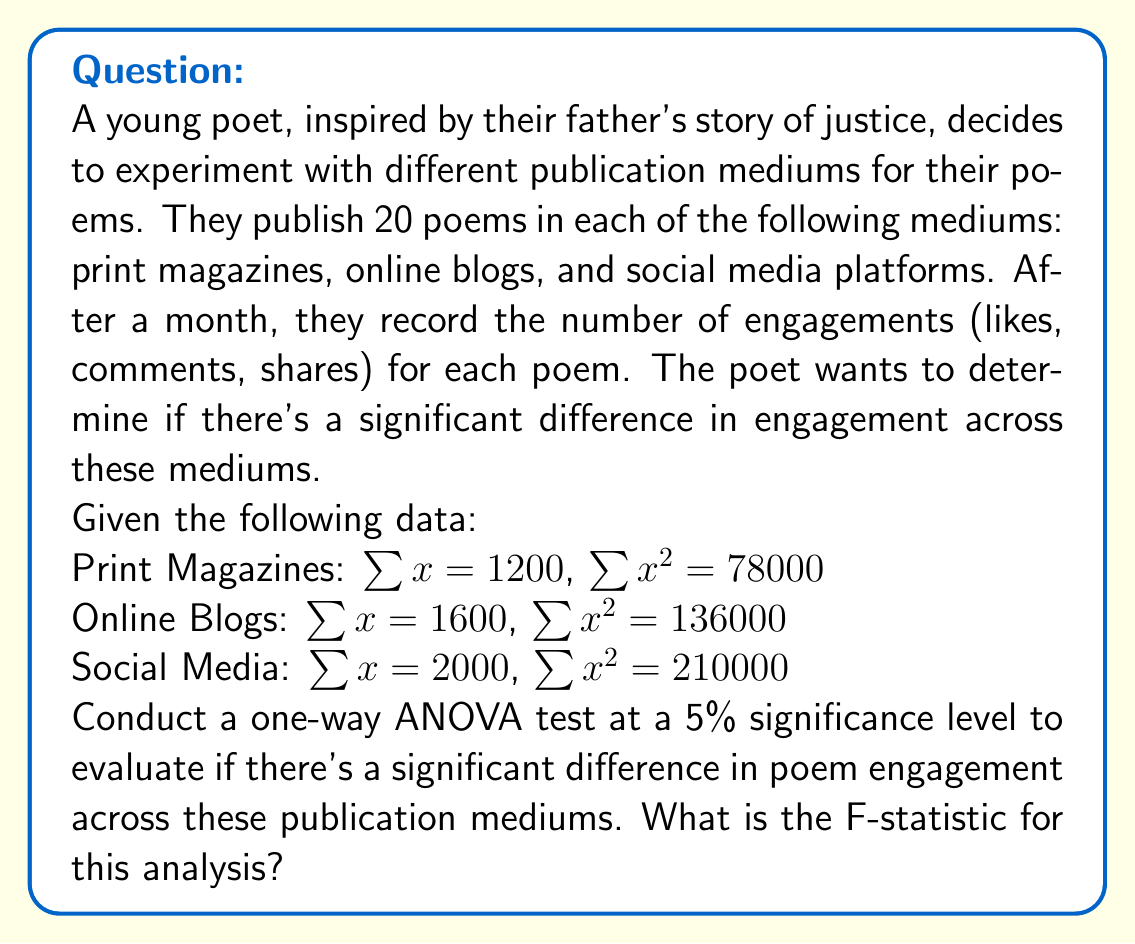Teach me how to tackle this problem. To conduct a one-way ANOVA, we need to follow these steps:

1. Calculate the total sum of squares (SST)
2. Calculate the between-group sum of squares (SSB)
3. Calculate the within-group sum of squares (SSW)
4. Calculate the degrees of freedom
5. Calculate the mean squares
6. Calculate the F-statistic

Step 1: Calculate SST
First, we need to find the grand mean:
$$\bar{X} = \frac{1200 + 1600 + 2000}{60} = 80$$

Now, we can calculate SST:
$$SST = (78000 + 136000 + 210000) - 60(80^2) = 424000 - 384000 = 40000$$

Step 2: Calculate SSB
We need to find the group means:
$$\bar{X}_1 = \frac{1200}{20} = 60$$
$$\bar{X}_2 = \frac{1600}{20} = 80$$
$$\bar{X}_3 = \frac{2000}{20} = 100$$

Now we can calculate SSB:
$$SSB = 20[(60-80)^2 + (80-80)^2 + (100-80)^2] = 20(400 + 0 + 400) = 16000$$

Step 3: Calculate SSW
$$SSW = SST - SSB = 40000 - 16000 = 24000$$

Step 4: Calculate degrees of freedom
$$df_{between} = k - 1 = 3 - 1 = 2$$
$$df_{within} = N - k = 60 - 3 = 57$$
Where k is the number of groups and N is the total number of observations.

Step 5: Calculate mean squares
$$MS_{between} = \frac{SSB}{df_{between}} = \frac{16000}{2} = 8000$$
$$MS_{within} = \frac{SSW}{df_{within}} = \frac{24000}{57} \approx 421.05$$

Step 6: Calculate F-statistic
$$F = \frac{MS_{between}}{MS_{within}} = \frac{8000}{421.05} \approx 19.00$$
Answer: The F-statistic for this one-way ANOVA analysis is approximately 19.00. 